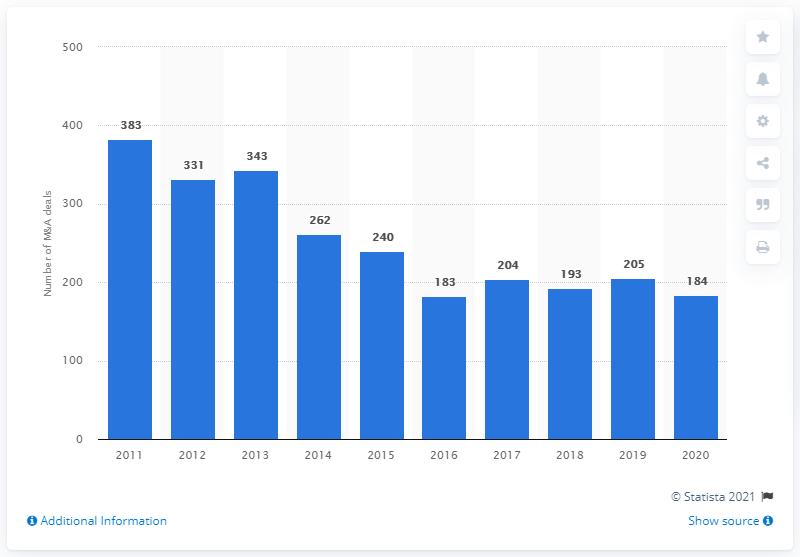Identify some key points in this picture. In Turkey, a total of 383 mergers and acquisitions (M&A) deals were completed from 2011 to 2020. In 2020, a total of 184 M&A deals were concluded. 